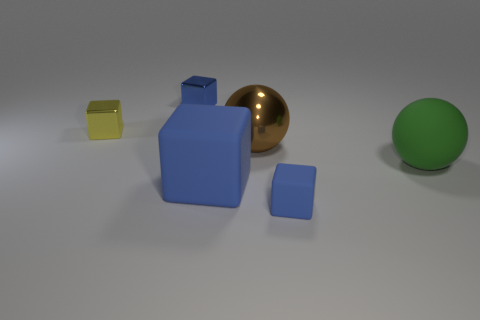Is there a shiny sphere that has the same color as the big rubber cube?
Provide a short and direct response. No. Is the number of tiny blue rubber cubes less than the number of large gray cubes?
Offer a terse response. No. How many objects are either green spheres or tiny blue things in front of the big green sphere?
Provide a short and direct response. 2. Are there any small blue blocks that have the same material as the green object?
Keep it short and to the point. Yes. What is the material of the blue cube that is the same size as the blue shiny object?
Provide a succinct answer. Rubber. What material is the tiny cube to the right of the tiny blue thing that is behind the green matte sphere?
Provide a succinct answer. Rubber. There is a small blue object behind the large rubber sphere; is its shape the same as the big green object?
Offer a terse response. No. There is a big block that is made of the same material as the green ball; what color is it?
Make the answer very short. Blue. What material is the small blue cube that is in front of the large green matte ball?
Your answer should be very brief. Rubber. There is a large blue object; does it have the same shape as the tiny blue object on the left side of the brown sphere?
Give a very brief answer. Yes. 